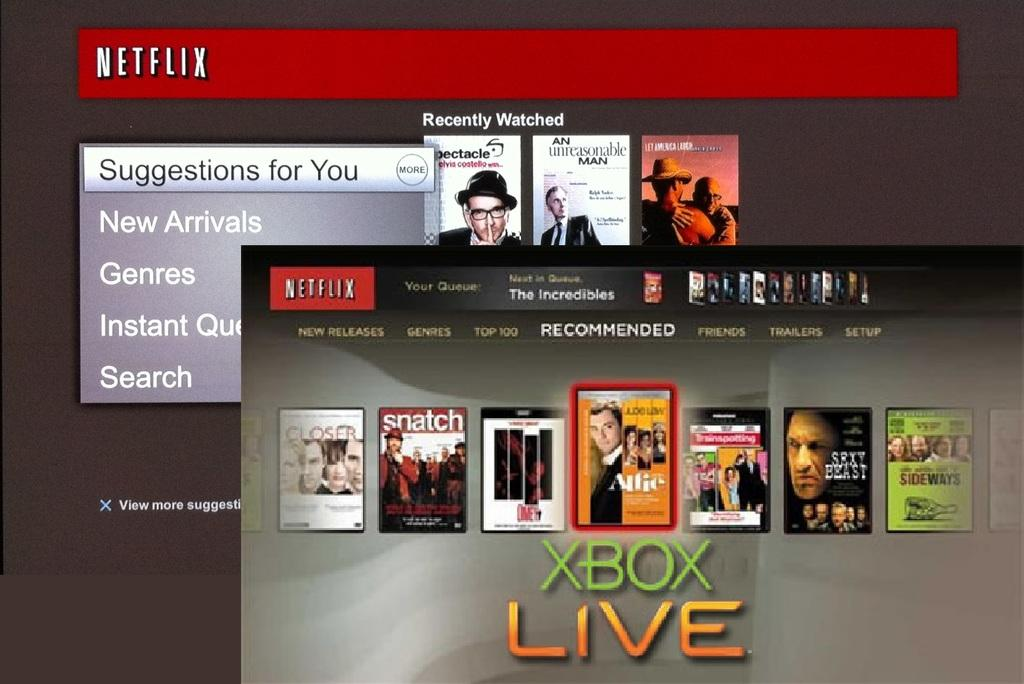<image>
Summarize the visual content of the image. Various movie selection and Xbox Live advertisement on Netflix. 